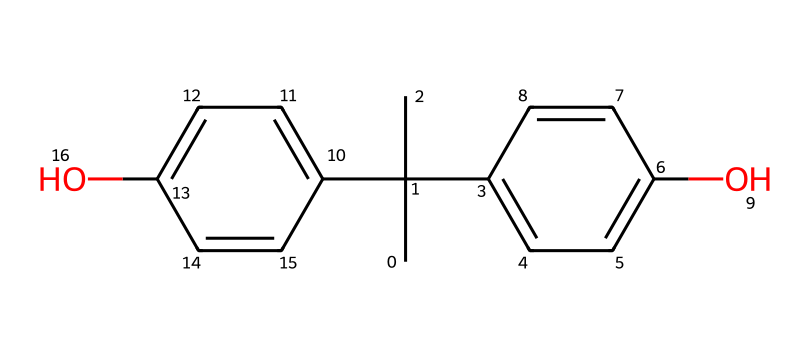How many carbon atoms are present in Bisphenol A? By analyzing the SMILES representation, we can count the 'C' symbols, which denote carbon atoms. In this structure, there are 15 carbon atoms visible.
Answer: 15 What is the degree of substitution of the hydroxyl groups in this chemical? The chemical structure shows two -OH (hydroxyl) groups, indicating this is a di-substituted phenol. Therefore, the degree of substitution is 2.
Answer: 2 What type of chemical compound is Bisphenol A? Bisphenol A is classified as a phenolic compound due to the presence of two hydroxyl (-OH) groups attached to aromatic rings. This defines it within the phenol chemical family.
Answer: phenolic How many hydrogen atoms are present in this molecule? The number of hydrogen atoms can be inferred from the structure and the degree of bonds around each carbon atom. Counting gives us 16 hydrogen atoms in Bisphenol A.
Answer: 16 What functional groups can be identified in this structure? The two hydroxyl (-OH) groups clearly identify functional groups. In addition, it has aromatic rings, making the functional groups recognizable as phenolic.
Answer: hydroxyl groups What is the total number of oxygen atoms in Bisphenol A? By inspecting the structure, we can see there are two hydroxyl groups, each contributing one oxygen atom, resulting in a total of two oxygen atoms in the molecule.
Answer: 2 